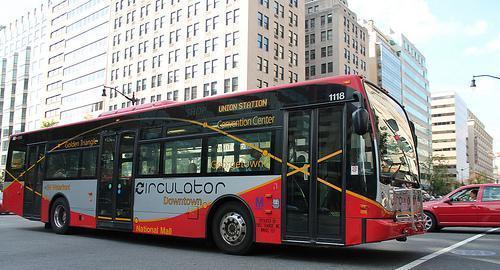How many buses are there?
Give a very brief answer. 1. 